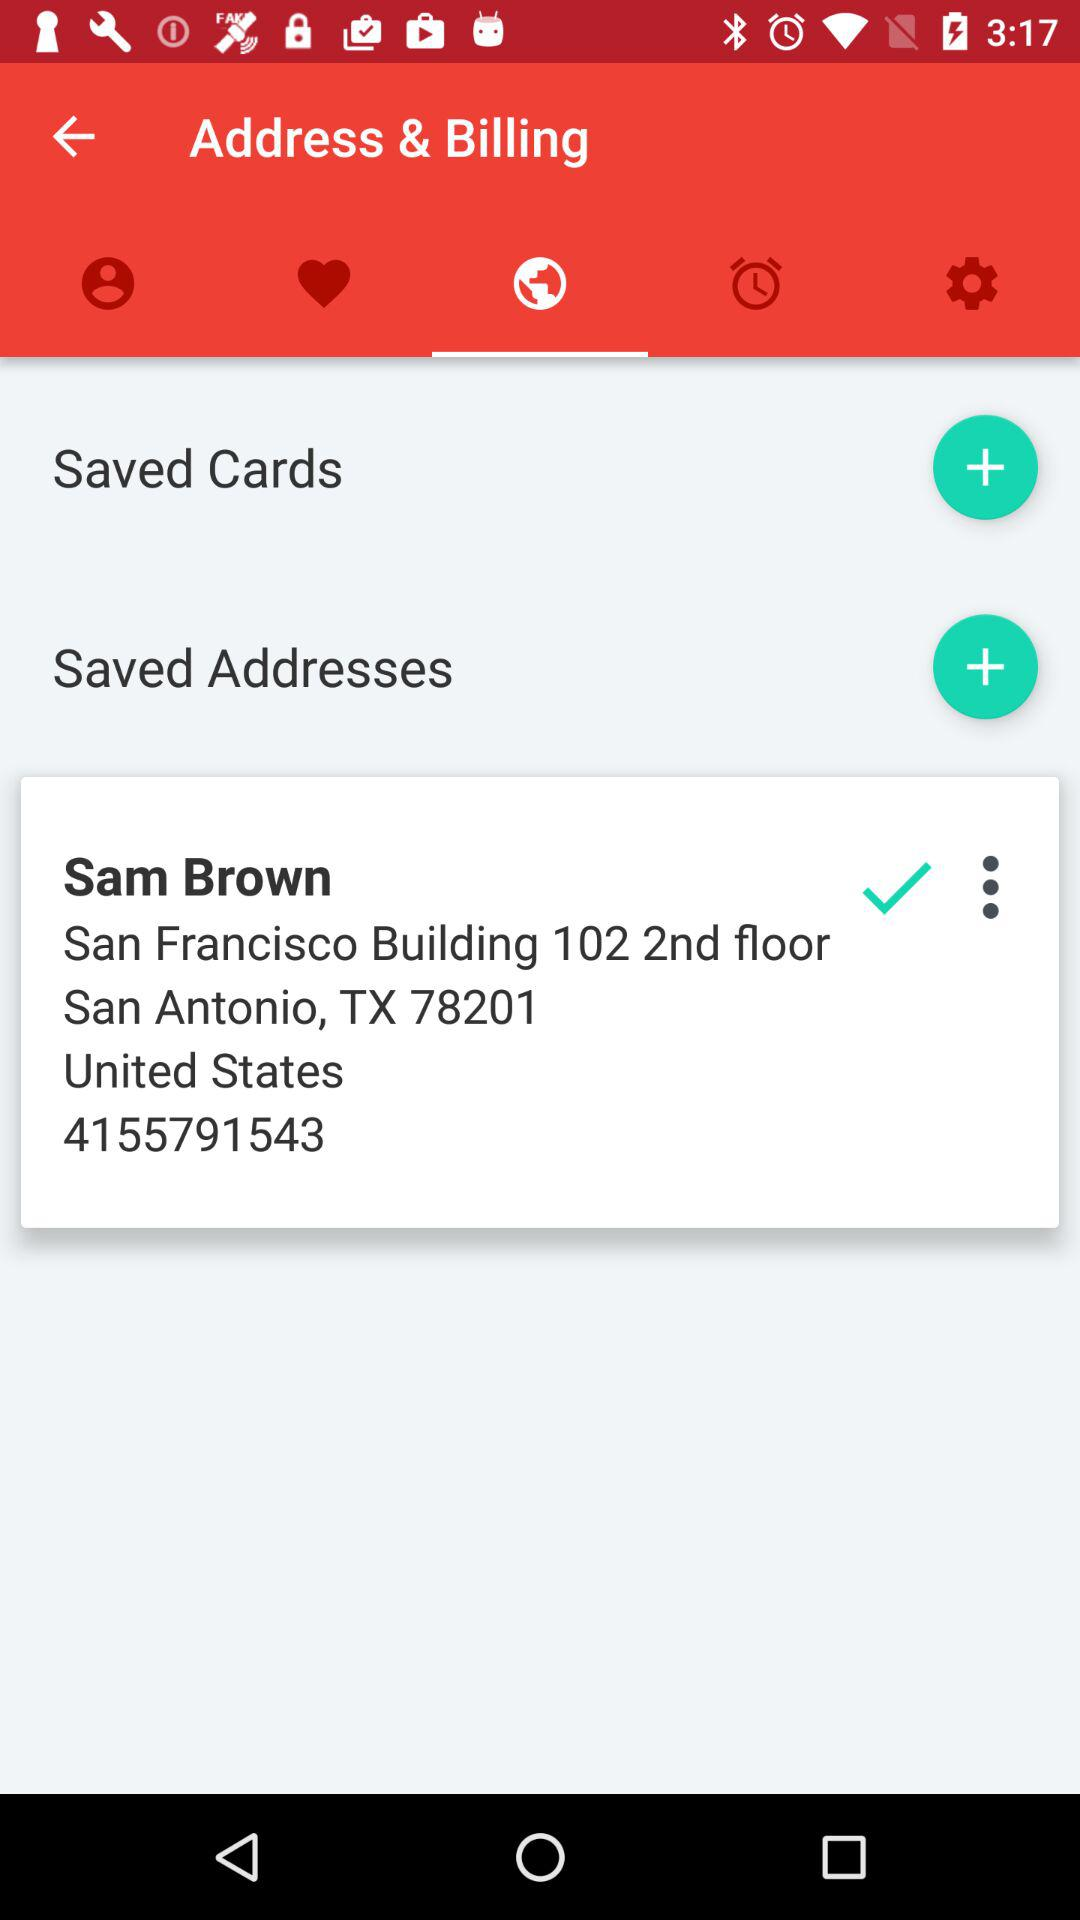What is the address of Sam Brown? The address of Sam Brown is San Francisco Building, 102, 2nd floor, San Antonio, TX 78201, United States. 